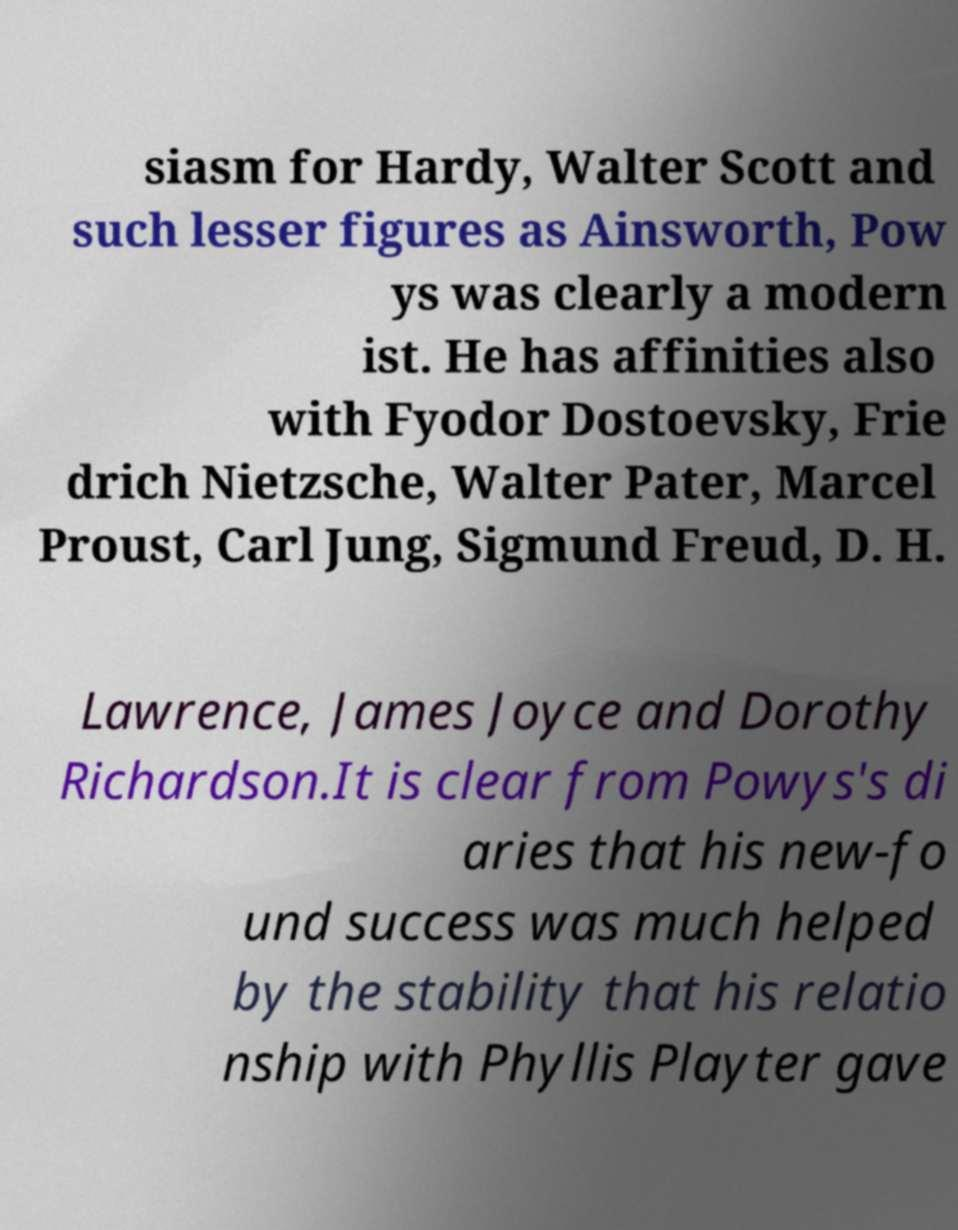Could you extract and type out the text from this image? siasm for Hardy, Walter Scott and such lesser figures as Ainsworth, Pow ys was clearly a modern ist. He has affinities also with Fyodor Dostoevsky, Frie drich Nietzsche, Walter Pater, Marcel Proust, Carl Jung, Sigmund Freud, D. H. Lawrence, James Joyce and Dorothy Richardson.It is clear from Powys's di aries that his new-fo und success was much helped by the stability that his relatio nship with Phyllis Playter gave 